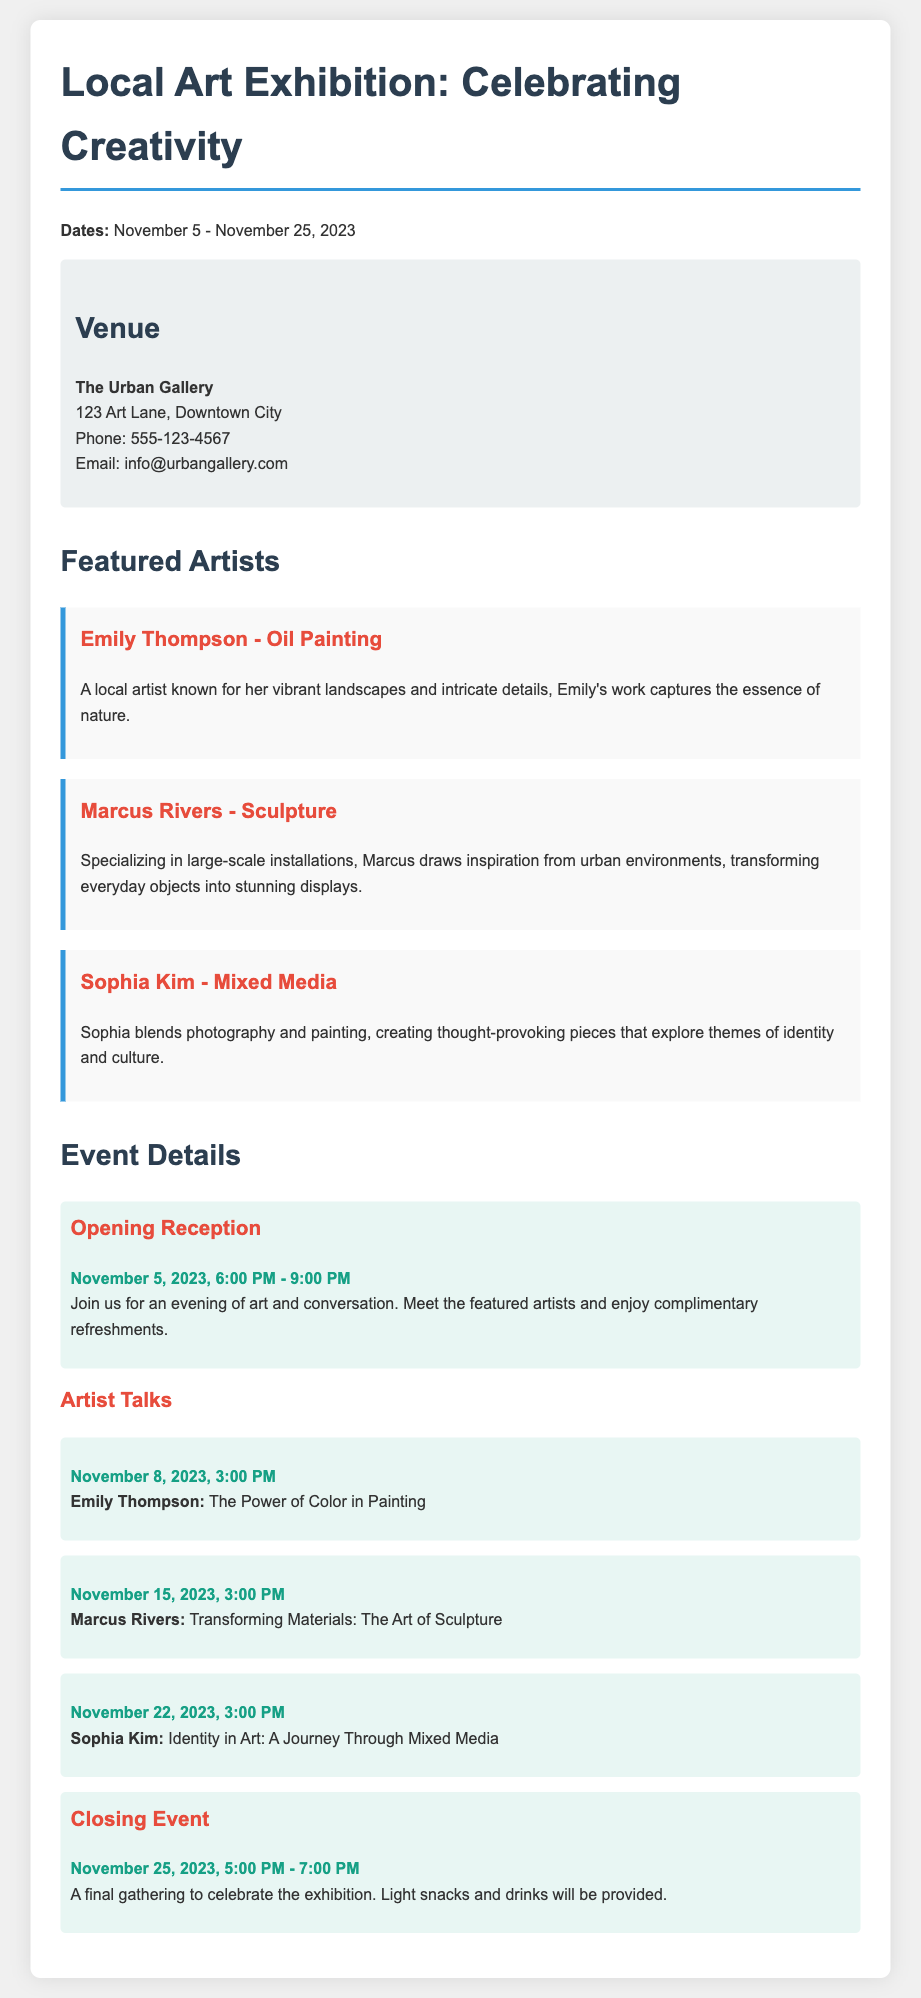What are the exhibition dates? The exhibition dates are clearly stated at the beginning of the document.
Answer: November 5 - November 25, 2023 What is the name of the venue? The venue is highlighted in the venue section of the document.
Answer: The Urban Gallery Who is the first featured artist? The first artist mentioned in the featured artists section is important information.
Answer: Emily Thompson What type of art does Marcus Rivers specialize in? The type of art each featured artist focuses on is described in their section.
Answer: Sculpture When is the closing event? The date and time of the closing event are specifically mentioned in the event details.
Answer: November 25, 2023, 5:00 PM - 7:00 PM How many artist talks are scheduled? The number of artist talks can be counted from the listed events in the document.
Answer: Three What theme does Sophia Kim's art explore? The themes explored by artists are given in their descriptions.
Answer: Identity and culture What time does the opening reception start? The starting time for the opening reception is specified in the event details section.
Answer: 6:00 PM Who will speak on November 15th? The document lists the artists and their respective dates for artist talks.
Answer: Marcus Rivers 